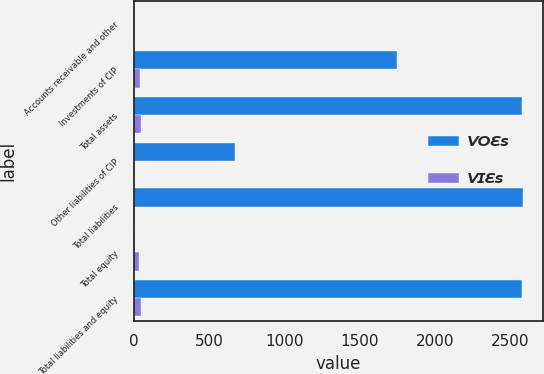Convert chart. <chart><loc_0><loc_0><loc_500><loc_500><stacked_bar_chart><ecel><fcel>Accounts receivable and other<fcel>Investments of CIP<fcel>Total assets<fcel>Other liabilities of CIP<fcel>Total liabilities<fcel>Total equity<fcel>Total liabilities and equity<nl><fcel>VOEs<fcel>11.3<fcel>1751.4<fcel>2579.2<fcel>674.7<fcel>2588.4<fcel>9.2<fcel>2579.2<nl><fcel>VIEs<fcel>9<fcel>40.1<fcel>49.1<fcel>11.8<fcel>11.8<fcel>37.3<fcel>49.1<nl></chart> 